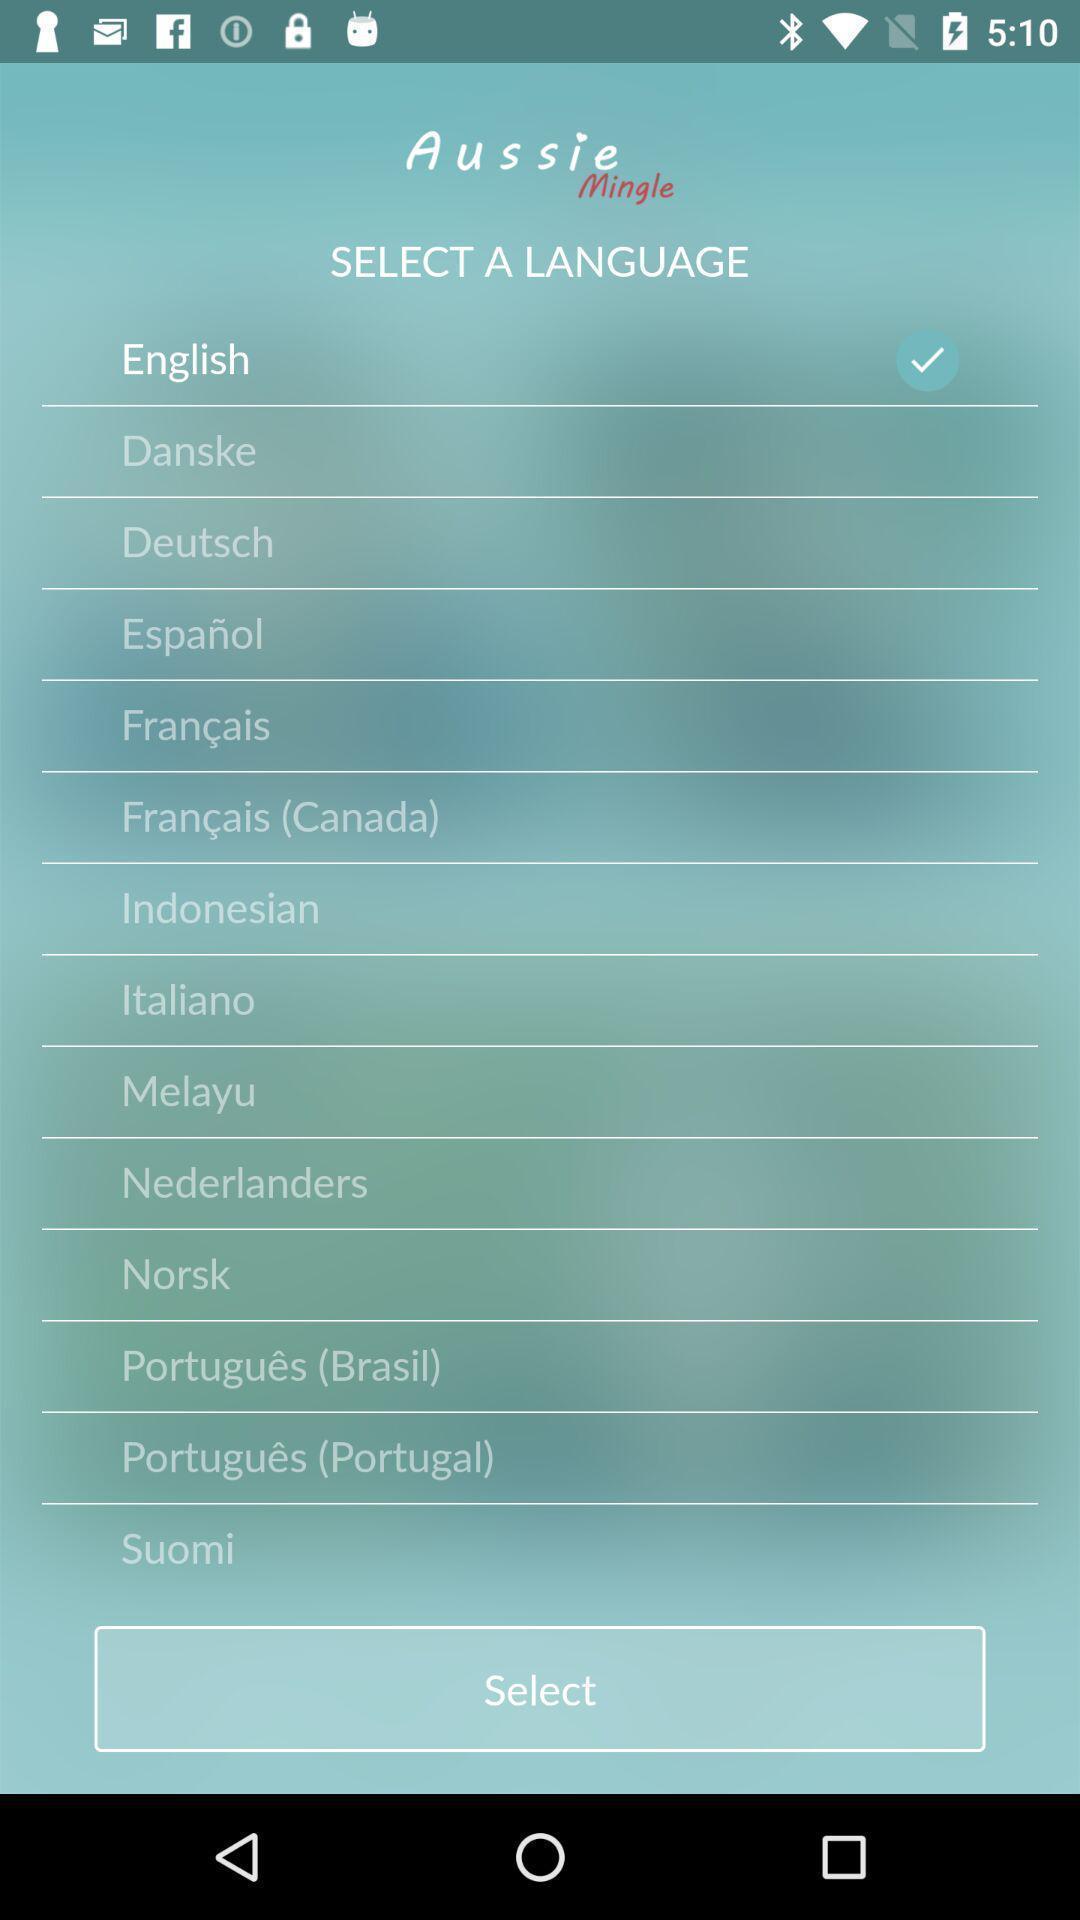Describe this image in words. Screen shows to select a language. 